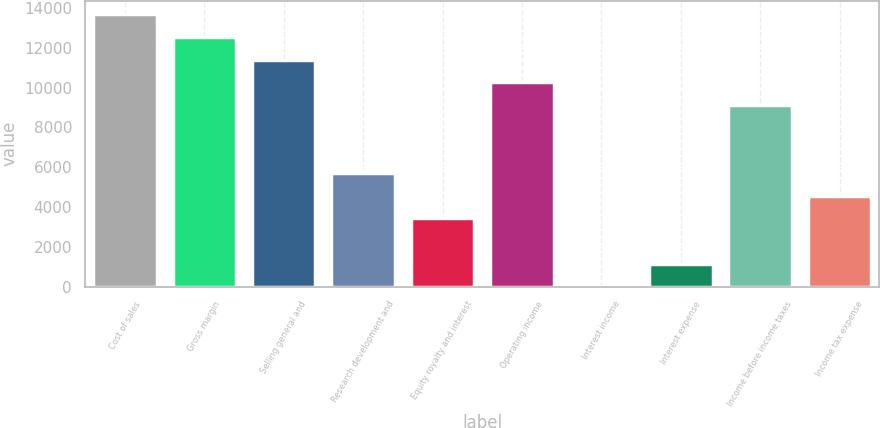Convert chart to OTSL. <chart><loc_0><loc_0><loc_500><loc_500><bar_chart><fcel>Cost of sales<fcel>Gross margin<fcel>Selling general and<fcel>Research development and<fcel>Equity royalty and interest<fcel>Operating income<fcel>Interest income<fcel>Interest expense<fcel>Income before income taxes<fcel>Income tax expense<nl><fcel>13678.8<fcel>12540.4<fcel>11402<fcel>5710<fcel>3433.2<fcel>10263.6<fcel>18<fcel>1156.4<fcel>9125.2<fcel>4571.6<nl></chart> 